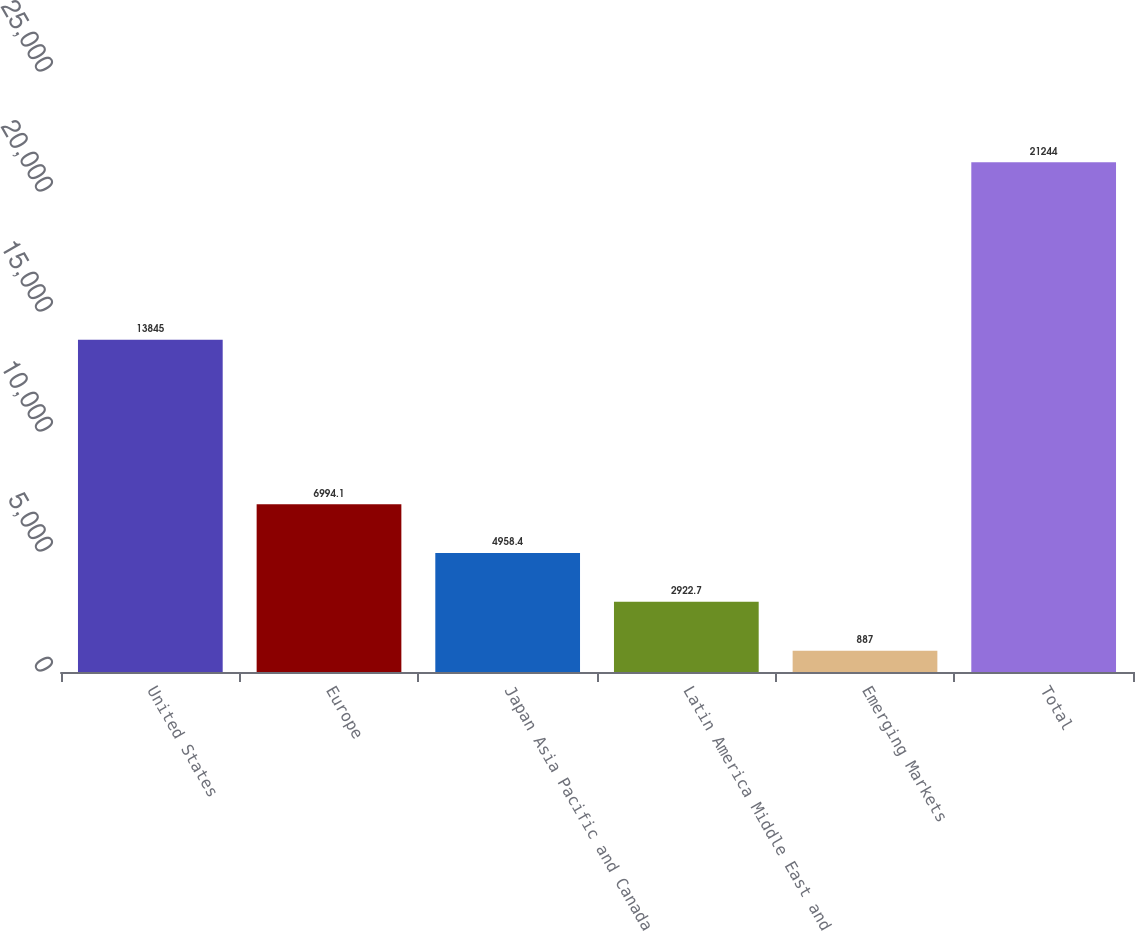<chart> <loc_0><loc_0><loc_500><loc_500><bar_chart><fcel>United States<fcel>Europe<fcel>Japan Asia Pacific and Canada<fcel>Latin America Middle East and<fcel>Emerging Markets<fcel>Total<nl><fcel>13845<fcel>6994.1<fcel>4958.4<fcel>2922.7<fcel>887<fcel>21244<nl></chart> 